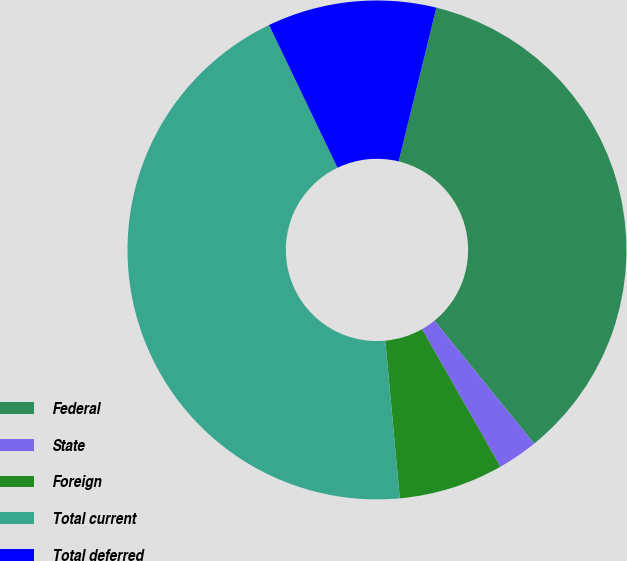Convert chart. <chart><loc_0><loc_0><loc_500><loc_500><pie_chart><fcel>Federal<fcel>State<fcel>Foreign<fcel>Total current<fcel>Total deferred<nl><fcel>35.32%<fcel>2.61%<fcel>6.78%<fcel>44.34%<fcel>10.95%<nl></chart> 